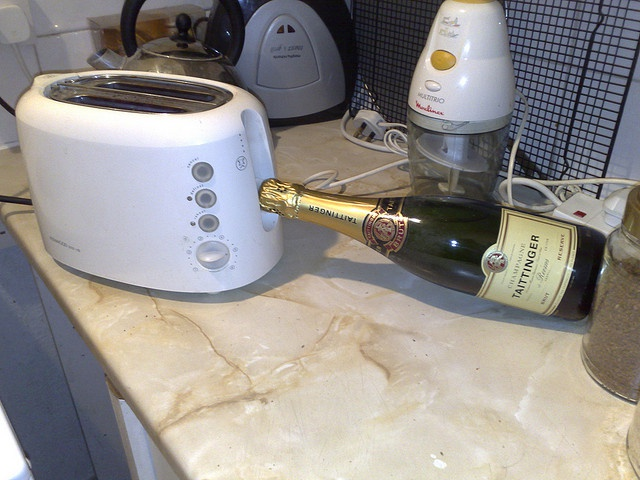Describe the objects in this image and their specific colors. I can see toaster in darkgray, lavender, and gray tones and bottle in darkgray, black, khaki, and gray tones in this image. 